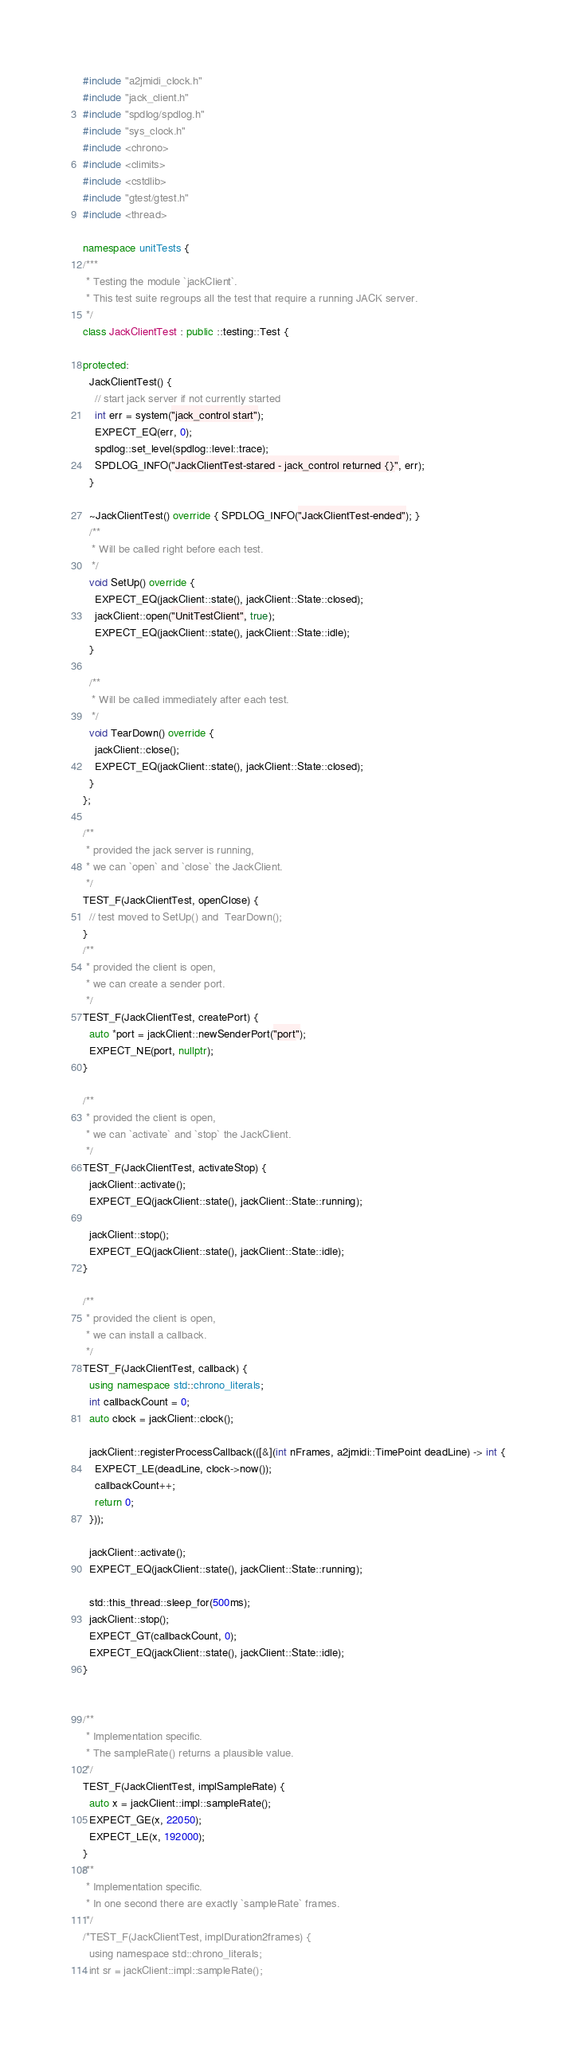<code> <loc_0><loc_0><loc_500><loc_500><_C++_>
#include "a2jmidi_clock.h"
#include "jack_client.h"
#include "spdlog/spdlog.h"
#include "sys_clock.h"
#include <chrono>
#include <climits>
#include <cstdlib>
#include "gtest/gtest.h"
#include <thread>

namespace unitTests {
/***
 * Testing the module `jackClient`.
 * This test suite regroups all the test that require a running JACK server.
 */
class JackClientTest : public ::testing::Test {

protected:
  JackClientTest() {
    // start jack server if not currently started
    int err = system("jack_control start");
    EXPECT_EQ(err, 0);
    spdlog::set_level(spdlog::level::trace);
    SPDLOG_INFO("JackClientTest-stared - jack_control returned {}", err);
  }

  ~JackClientTest() override { SPDLOG_INFO("JackClientTest-ended"); }
  /**
   * Will be called right before each test.
   */
  void SetUp() override {
    EXPECT_EQ(jackClient::state(), jackClient::State::closed);
    jackClient::open("UnitTestClient", true);
    EXPECT_EQ(jackClient::state(), jackClient::State::idle);
  }

  /**
   * Will be called immediately after each test.
   */
  void TearDown() override {
    jackClient::close();
    EXPECT_EQ(jackClient::state(), jackClient::State::closed);
  }
};

/**
 * provided the jack server is running,
 * we can `open` and `close` the JackClient.
 */
TEST_F(JackClientTest, openClose) {
  // test moved to SetUp() and  TearDown();
}
/**
 * provided the client is open,
 * we can create a sender port.
 */
TEST_F(JackClientTest, createPort) {
  auto *port = jackClient::newSenderPort("port");
  EXPECT_NE(port, nullptr);
}

/**
 * provided the client is open,
 * we can `activate` and `stop` the JackClient.
 */
TEST_F(JackClientTest, activateStop) {
  jackClient::activate();
  EXPECT_EQ(jackClient::state(), jackClient::State::running);

  jackClient::stop();
  EXPECT_EQ(jackClient::state(), jackClient::State::idle);
}

/**
 * provided the client is open,
 * we can install a callback.
 */
TEST_F(JackClientTest, callback) {
  using namespace std::chrono_literals;
  int callbackCount = 0;
  auto clock = jackClient::clock();

  jackClient::registerProcessCallback(([&](int nFrames, a2jmidi::TimePoint deadLine) -> int {
    EXPECT_LE(deadLine, clock->now());
    callbackCount++;
    return 0;
  }));

  jackClient::activate();
  EXPECT_EQ(jackClient::state(), jackClient::State::running);

  std::this_thread::sleep_for(500ms);
  jackClient::stop();
  EXPECT_GT(callbackCount, 0);
  EXPECT_EQ(jackClient::state(), jackClient::State::idle);
}


/**
 * Implementation specific.
 * The sampleRate() returns a plausible value.
 */
TEST_F(JackClientTest, implSampleRate) {
  auto x = jackClient::impl::sampleRate();
  EXPECT_GE(x, 22050);
  EXPECT_LE(x, 192000);
}
/**
 * Implementation specific.
 * In one second there are exactly `sampleRate` frames.
 */
/*TEST_F(JackClientTest, implDuration2frames) {
  using namespace std::chrono_literals;
  int sr = jackClient::impl::sampleRate();</code> 